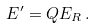Convert formula to latex. <formula><loc_0><loc_0><loc_500><loc_500>E ^ { \prime } = Q E _ { R } \, .</formula> 